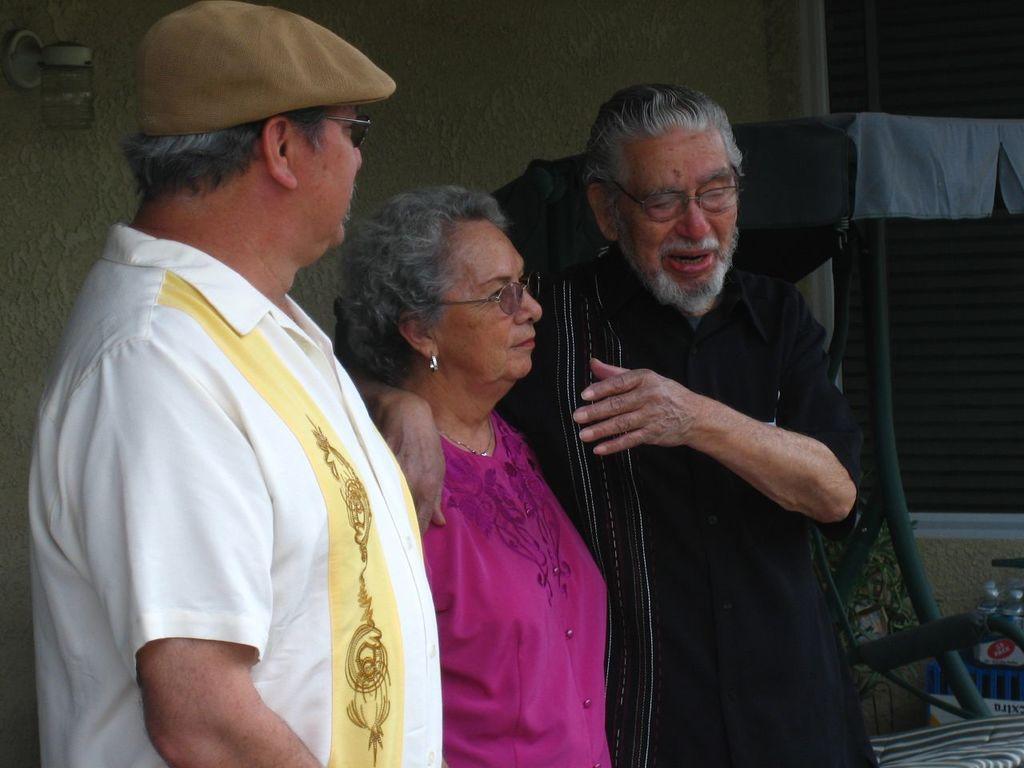Describe this image in one or two sentences. In this image we can two men and one woman is standing, one man is wearing white shirt and the other one is wearing black dress. The woman is wearing pink color dress. Behind them one green color chair and window is present. 